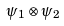<formula> <loc_0><loc_0><loc_500><loc_500>\psi _ { 1 } \otimes \psi _ { 2 }</formula> 